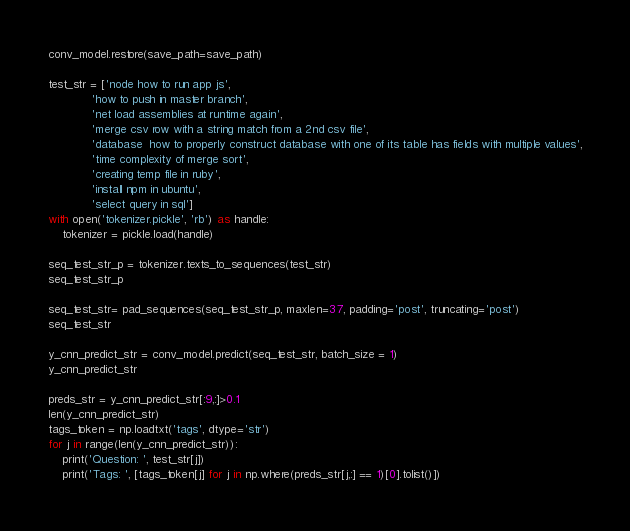<code> <loc_0><loc_0><loc_500><loc_500><_Python_>conv_model.restore(save_path=save_path)

test_str = ['node how to run app js',
            'how to push in master branch',
            'net load assemblies at runtime again',
            'merge csv row with a string match from a 2nd csv file',
            'database  how to properly construct database with one of its table has fields with multiple values',
            'time complexity of merge sort',
            'creating temp file in ruby',
            'install npm in ubuntu',
            'select query in sql']
with open('tokenizer.pickle', 'rb') as handle:
    tokenizer = pickle.load(handle)

seq_test_str_p = tokenizer.texts_to_sequences(test_str)
seq_test_str_p

seq_test_str= pad_sequences(seq_test_str_p, maxlen=37, padding='post', truncating='post')
seq_test_str

y_cnn_predict_str = conv_model.predict(seq_test_str, batch_size = 1)
y_cnn_predict_str

preds_str = y_cnn_predict_str[:9,:]>0.1
len(y_cnn_predict_str)
tags_token = np.loadtxt('tags', dtype='str')
for j in range(len(y_cnn_predict_str)):
    print('Question: ', test_str[j])
    print('Tags: ', [tags_token[j] for j in np.where(preds_str[j,:] == 1)[0].tolist()])
</code> 